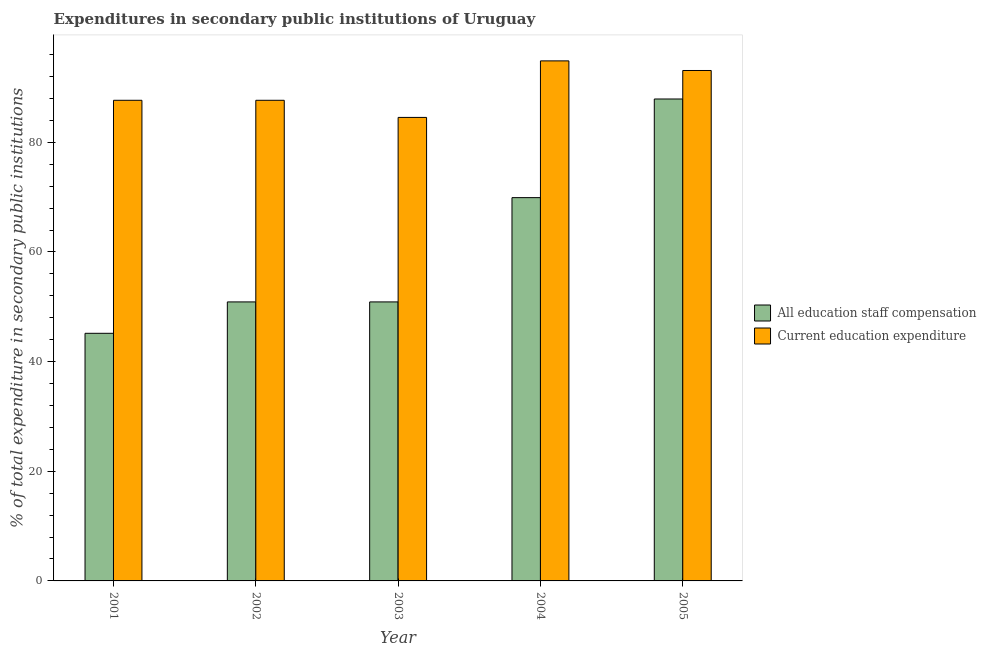How many different coloured bars are there?
Your answer should be compact. 2. Are the number of bars per tick equal to the number of legend labels?
Your answer should be very brief. Yes. How many bars are there on the 4th tick from the left?
Offer a very short reply. 2. In how many cases, is the number of bars for a given year not equal to the number of legend labels?
Provide a succinct answer. 0. What is the expenditure in staff compensation in 2005?
Your answer should be very brief. 87.9. Across all years, what is the maximum expenditure in education?
Make the answer very short. 94.86. Across all years, what is the minimum expenditure in education?
Your answer should be very brief. 84.55. In which year was the expenditure in education minimum?
Give a very brief answer. 2003. What is the total expenditure in staff compensation in the graph?
Make the answer very short. 304.77. What is the difference between the expenditure in staff compensation in 2002 and that in 2004?
Ensure brevity in your answer.  -19.02. What is the difference between the expenditure in education in 2003 and the expenditure in staff compensation in 2002?
Keep it short and to the point. -3.12. What is the average expenditure in education per year?
Your response must be concise. 89.57. In how many years, is the expenditure in education greater than 20 %?
Your answer should be very brief. 5. What is the ratio of the expenditure in staff compensation in 2001 to that in 2002?
Your answer should be compact. 0.89. Is the expenditure in staff compensation in 2002 less than that in 2004?
Offer a very short reply. Yes. Is the difference between the expenditure in staff compensation in 2003 and 2004 greater than the difference between the expenditure in education in 2003 and 2004?
Your answer should be very brief. No. What is the difference between the highest and the second highest expenditure in education?
Provide a succinct answer. 1.75. What is the difference between the highest and the lowest expenditure in education?
Your answer should be very brief. 10.31. In how many years, is the expenditure in education greater than the average expenditure in education taken over all years?
Your answer should be very brief. 2. Is the sum of the expenditure in education in 2003 and 2005 greater than the maximum expenditure in staff compensation across all years?
Provide a short and direct response. Yes. What does the 1st bar from the left in 2005 represents?
Provide a succinct answer. All education staff compensation. What does the 2nd bar from the right in 2003 represents?
Provide a succinct answer. All education staff compensation. How many bars are there?
Provide a short and direct response. 10. How many years are there in the graph?
Offer a very short reply. 5. Are the values on the major ticks of Y-axis written in scientific E-notation?
Offer a very short reply. No. Does the graph contain grids?
Ensure brevity in your answer.  No. Where does the legend appear in the graph?
Keep it short and to the point. Center right. How are the legend labels stacked?
Offer a very short reply. Vertical. What is the title of the graph?
Your answer should be very brief. Expenditures in secondary public institutions of Uruguay. Does "Investment in Transport" appear as one of the legend labels in the graph?
Your answer should be compact. No. What is the label or title of the Y-axis?
Ensure brevity in your answer.  % of total expenditure in secondary public institutions. What is the % of total expenditure in secondary public institutions of All education staff compensation in 2001?
Provide a succinct answer. 45.17. What is the % of total expenditure in secondary public institutions in Current education expenditure in 2001?
Make the answer very short. 87.67. What is the % of total expenditure in secondary public institutions in All education staff compensation in 2002?
Your answer should be compact. 50.89. What is the % of total expenditure in secondary public institutions of Current education expenditure in 2002?
Your answer should be very brief. 87.67. What is the % of total expenditure in secondary public institutions of All education staff compensation in 2003?
Offer a terse response. 50.89. What is the % of total expenditure in secondary public institutions of Current education expenditure in 2003?
Ensure brevity in your answer.  84.55. What is the % of total expenditure in secondary public institutions of All education staff compensation in 2004?
Your answer should be very brief. 69.91. What is the % of total expenditure in secondary public institutions in Current education expenditure in 2004?
Offer a very short reply. 94.86. What is the % of total expenditure in secondary public institutions in All education staff compensation in 2005?
Your answer should be compact. 87.9. What is the % of total expenditure in secondary public institutions in Current education expenditure in 2005?
Your answer should be very brief. 93.11. Across all years, what is the maximum % of total expenditure in secondary public institutions in All education staff compensation?
Your answer should be very brief. 87.9. Across all years, what is the maximum % of total expenditure in secondary public institutions in Current education expenditure?
Offer a terse response. 94.86. Across all years, what is the minimum % of total expenditure in secondary public institutions in All education staff compensation?
Make the answer very short. 45.17. Across all years, what is the minimum % of total expenditure in secondary public institutions in Current education expenditure?
Give a very brief answer. 84.55. What is the total % of total expenditure in secondary public institutions in All education staff compensation in the graph?
Offer a terse response. 304.77. What is the total % of total expenditure in secondary public institutions of Current education expenditure in the graph?
Your answer should be compact. 447.85. What is the difference between the % of total expenditure in secondary public institutions in All education staff compensation in 2001 and that in 2002?
Offer a terse response. -5.72. What is the difference between the % of total expenditure in secondary public institutions in All education staff compensation in 2001 and that in 2003?
Provide a short and direct response. -5.72. What is the difference between the % of total expenditure in secondary public institutions in Current education expenditure in 2001 and that in 2003?
Your response must be concise. 3.12. What is the difference between the % of total expenditure in secondary public institutions of All education staff compensation in 2001 and that in 2004?
Your response must be concise. -24.75. What is the difference between the % of total expenditure in secondary public institutions in Current education expenditure in 2001 and that in 2004?
Provide a succinct answer. -7.19. What is the difference between the % of total expenditure in secondary public institutions of All education staff compensation in 2001 and that in 2005?
Offer a terse response. -42.74. What is the difference between the % of total expenditure in secondary public institutions of Current education expenditure in 2001 and that in 2005?
Your response must be concise. -5.44. What is the difference between the % of total expenditure in secondary public institutions of All education staff compensation in 2002 and that in 2003?
Give a very brief answer. 0. What is the difference between the % of total expenditure in secondary public institutions in Current education expenditure in 2002 and that in 2003?
Ensure brevity in your answer.  3.12. What is the difference between the % of total expenditure in secondary public institutions in All education staff compensation in 2002 and that in 2004?
Your answer should be very brief. -19.02. What is the difference between the % of total expenditure in secondary public institutions in Current education expenditure in 2002 and that in 2004?
Keep it short and to the point. -7.19. What is the difference between the % of total expenditure in secondary public institutions in All education staff compensation in 2002 and that in 2005?
Give a very brief answer. -37.01. What is the difference between the % of total expenditure in secondary public institutions in Current education expenditure in 2002 and that in 2005?
Provide a succinct answer. -5.44. What is the difference between the % of total expenditure in secondary public institutions of All education staff compensation in 2003 and that in 2004?
Ensure brevity in your answer.  -19.02. What is the difference between the % of total expenditure in secondary public institutions in Current education expenditure in 2003 and that in 2004?
Offer a terse response. -10.31. What is the difference between the % of total expenditure in secondary public institutions of All education staff compensation in 2003 and that in 2005?
Your answer should be compact. -37.01. What is the difference between the % of total expenditure in secondary public institutions in Current education expenditure in 2003 and that in 2005?
Give a very brief answer. -8.56. What is the difference between the % of total expenditure in secondary public institutions in All education staff compensation in 2004 and that in 2005?
Keep it short and to the point. -17.99. What is the difference between the % of total expenditure in secondary public institutions in Current education expenditure in 2004 and that in 2005?
Provide a succinct answer. 1.75. What is the difference between the % of total expenditure in secondary public institutions in All education staff compensation in 2001 and the % of total expenditure in secondary public institutions in Current education expenditure in 2002?
Give a very brief answer. -42.5. What is the difference between the % of total expenditure in secondary public institutions in All education staff compensation in 2001 and the % of total expenditure in secondary public institutions in Current education expenditure in 2003?
Your response must be concise. -39.38. What is the difference between the % of total expenditure in secondary public institutions of All education staff compensation in 2001 and the % of total expenditure in secondary public institutions of Current education expenditure in 2004?
Your response must be concise. -49.69. What is the difference between the % of total expenditure in secondary public institutions in All education staff compensation in 2001 and the % of total expenditure in secondary public institutions in Current education expenditure in 2005?
Offer a very short reply. -47.94. What is the difference between the % of total expenditure in secondary public institutions of All education staff compensation in 2002 and the % of total expenditure in secondary public institutions of Current education expenditure in 2003?
Keep it short and to the point. -33.66. What is the difference between the % of total expenditure in secondary public institutions in All education staff compensation in 2002 and the % of total expenditure in secondary public institutions in Current education expenditure in 2004?
Offer a very short reply. -43.97. What is the difference between the % of total expenditure in secondary public institutions of All education staff compensation in 2002 and the % of total expenditure in secondary public institutions of Current education expenditure in 2005?
Give a very brief answer. -42.22. What is the difference between the % of total expenditure in secondary public institutions in All education staff compensation in 2003 and the % of total expenditure in secondary public institutions in Current education expenditure in 2004?
Give a very brief answer. -43.97. What is the difference between the % of total expenditure in secondary public institutions in All education staff compensation in 2003 and the % of total expenditure in secondary public institutions in Current education expenditure in 2005?
Your answer should be very brief. -42.22. What is the difference between the % of total expenditure in secondary public institutions in All education staff compensation in 2004 and the % of total expenditure in secondary public institutions in Current education expenditure in 2005?
Provide a succinct answer. -23.19. What is the average % of total expenditure in secondary public institutions of All education staff compensation per year?
Provide a short and direct response. 60.95. What is the average % of total expenditure in secondary public institutions of Current education expenditure per year?
Offer a very short reply. 89.57. In the year 2001, what is the difference between the % of total expenditure in secondary public institutions in All education staff compensation and % of total expenditure in secondary public institutions in Current education expenditure?
Make the answer very short. -42.5. In the year 2002, what is the difference between the % of total expenditure in secondary public institutions in All education staff compensation and % of total expenditure in secondary public institutions in Current education expenditure?
Provide a succinct answer. -36.78. In the year 2003, what is the difference between the % of total expenditure in secondary public institutions of All education staff compensation and % of total expenditure in secondary public institutions of Current education expenditure?
Your response must be concise. -33.66. In the year 2004, what is the difference between the % of total expenditure in secondary public institutions in All education staff compensation and % of total expenditure in secondary public institutions in Current education expenditure?
Make the answer very short. -24.94. In the year 2005, what is the difference between the % of total expenditure in secondary public institutions in All education staff compensation and % of total expenditure in secondary public institutions in Current education expenditure?
Provide a short and direct response. -5.2. What is the ratio of the % of total expenditure in secondary public institutions in All education staff compensation in 2001 to that in 2002?
Make the answer very short. 0.89. What is the ratio of the % of total expenditure in secondary public institutions of Current education expenditure in 2001 to that in 2002?
Your answer should be very brief. 1. What is the ratio of the % of total expenditure in secondary public institutions in All education staff compensation in 2001 to that in 2003?
Ensure brevity in your answer.  0.89. What is the ratio of the % of total expenditure in secondary public institutions in Current education expenditure in 2001 to that in 2003?
Offer a very short reply. 1.04. What is the ratio of the % of total expenditure in secondary public institutions of All education staff compensation in 2001 to that in 2004?
Make the answer very short. 0.65. What is the ratio of the % of total expenditure in secondary public institutions of Current education expenditure in 2001 to that in 2004?
Make the answer very short. 0.92. What is the ratio of the % of total expenditure in secondary public institutions of All education staff compensation in 2001 to that in 2005?
Your response must be concise. 0.51. What is the ratio of the % of total expenditure in secondary public institutions in Current education expenditure in 2001 to that in 2005?
Ensure brevity in your answer.  0.94. What is the ratio of the % of total expenditure in secondary public institutions in All education staff compensation in 2002 to that in 2003?
Provide a succinct answer. 1. What is the ratio of the % of total expenditure in secondary public institutions of Current education expenditure in 2002 to that in 2003?
Ensure brevity in your answer.  1.04. What is the ratio of the % of total expenditure in secondary public institutions of All education staff compensation in 2002 to that in 2004?
Keep it short and to the point. 0.73. What is the ratio of the % of total expenditure in secondary public institutions of Current education expenditure in 2002 to that in 2004?
Your answer should be very brief. 0.92. What is the ratio of the % of total expenditure in secondary public institutions in All education staff compensation in 2002 to that in 2005?
Your response must be concise. 0.58. What is the ratio of the % of total expenditure in secondary public institutions in Current education expenditure in 2002 to that in 2005?
Your answer should be compact. 0.94. What is the ratio of the % of total expenditure in secondary public institutions of All education staff compensation in 2003 to that in 2004?
Offer a terse response. 0.73. What is the ratio of the % of total expenditure in secondary public institutions in Current education expenditure in 2003 to that in 2004?
Make the answer very short. 0.89. What is the ratio of the % of total expenditure in secondary public institutions in All education staff compensation in 2003 to that in 2005?
Offer a very short reply. 0.58. What is the ratio of the % of total expenditure in secondary public institutions in Current education expenditure in 2003 to that in 2005?
Ensure brevity in your answer.  0.91. What is the ratio of the % of total expenditure in secondary public institutions of All education staff compensation in 2004 to that in 2005?
Keep it short and to the point. 0.8. What is the ratio of the % of total expenditure in secondary public institutions in Current education expenditure in 2004 to that in 2005?
Your response must be concise. 1.02. What is the difference between the highest and the second highest % of total expenditure in secondary public institutions of All education staff compensation?
Provide a short and direct response. 17.99. What is the difference between the highest and the second highest % of total expenditure in secondary public institutions of Current education expenditure?
Your answer should be compact. 1.75. What is the difference between the highest and the lowest % of total expenditure in secondary public institutions of All education staff compensation?
Provide a short and direct response. 42.74. What is the difference between the highest and the lowest % of total expenditure in secondary public institutions in Current education expenditure?
Your answer should be compact. 10.31. 